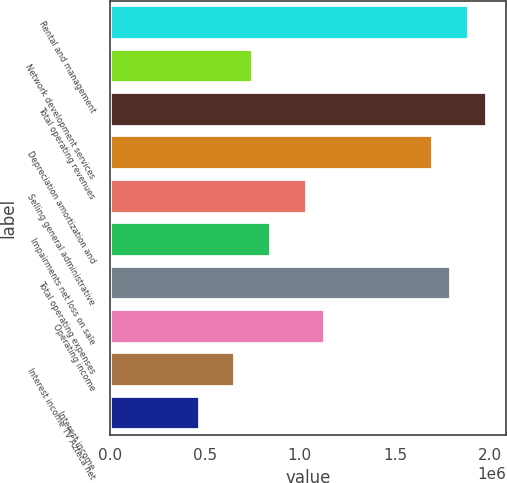Convert chart. <chart><loc_0><loc_0><loc_500><loc_500><bar_chart><fcel>Rental and management<fcel>Network development services<fcel>Total operating revenues<fcel>Depreciation amortization and<fcel>Selling general administrative<fcel>Impairments net loss on sale<fcel>Total operating expenses<fcel>Operating income<fcel>Interest income TV Azteca net<fcel>Interest income<nl><fcel>1.88957e+06<fcel>755829<fcel>1.98405e+06<fcel>1.70061e+06<fcel>1.03926e+06<fcel>850307<fcel>1.79509e+06<fcel>1.13374e+06<fcel>661350<fcel>472393<nl></chart> 